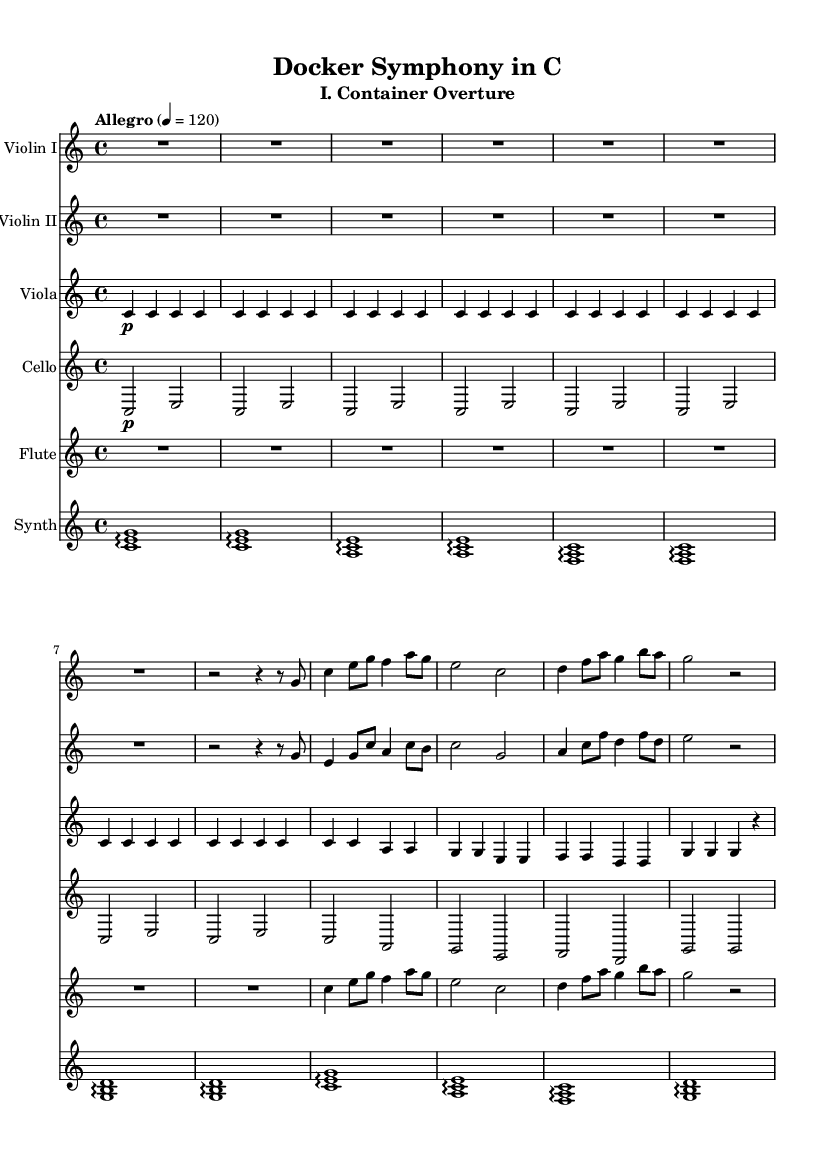What is the key signature of this music? The key signature is C major, which is indicated by the absence of sharps or flats in the music notation.
Answer: C major What is the time signature of the piece? The time signature shown at the beginning of the sheet music is 4/4, which indicates that there are four beats in a measure and the quarter note gets the beat.
Answer: 4/4 What is the tempo marking of the symphony? The tempo marking is indicated as "Allegro" with a metronome marking of 120 beats per minute, suggesting a lively tempo.
Answer: Allegro 4 = 120 How many measures are there in the violin I part? By counting the measures in the violin I part, there are a total of 8 measures in the excerpt provided.
Answer: 8 What instruments are featured in this symphony? The symphony includes Violin I, Violin II, Viola, Cello, Flute, and Synthesizer. Each is notated on a separate staff in the score.
Answer: Violin I, Violin II, Viola, Cello, Flute, Synthesizer Which instrument plays the electronic elements in this symphony? The synthesizer is the instrument designated in the score for playing electronic elements, as indicated in the last staff labeled "Synth."
Answer: Synthesizer What texture is primarily used in the viola part for most of the measures? The viola part mainly uses a homorhythmic texture, indicated by the repeated quarter notes throughout the measures, providing a sustained sound.
Answer: Homorhythmic 